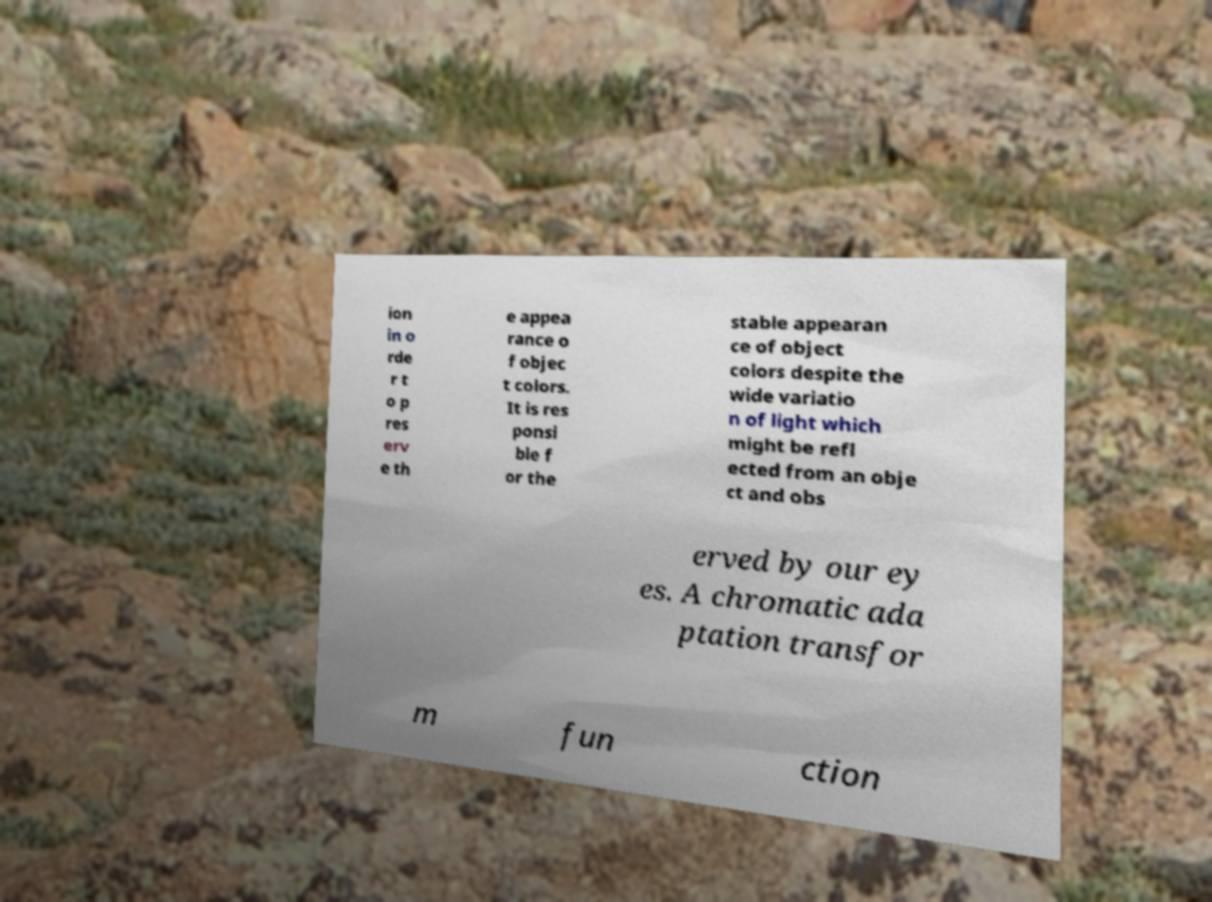There's text embedded in this image that I need extracted. Can you transcribe it verbatim? ion in o rde r t o p res erv e th e appea rance o f objec t colors. It is res ponsi ble f or the stable appearan ce of object colors despite the wide variatio n of light which might be refl ected from an obje ct and obs erved by our ey es. A chromatic ada ptation transfor m fun ction 